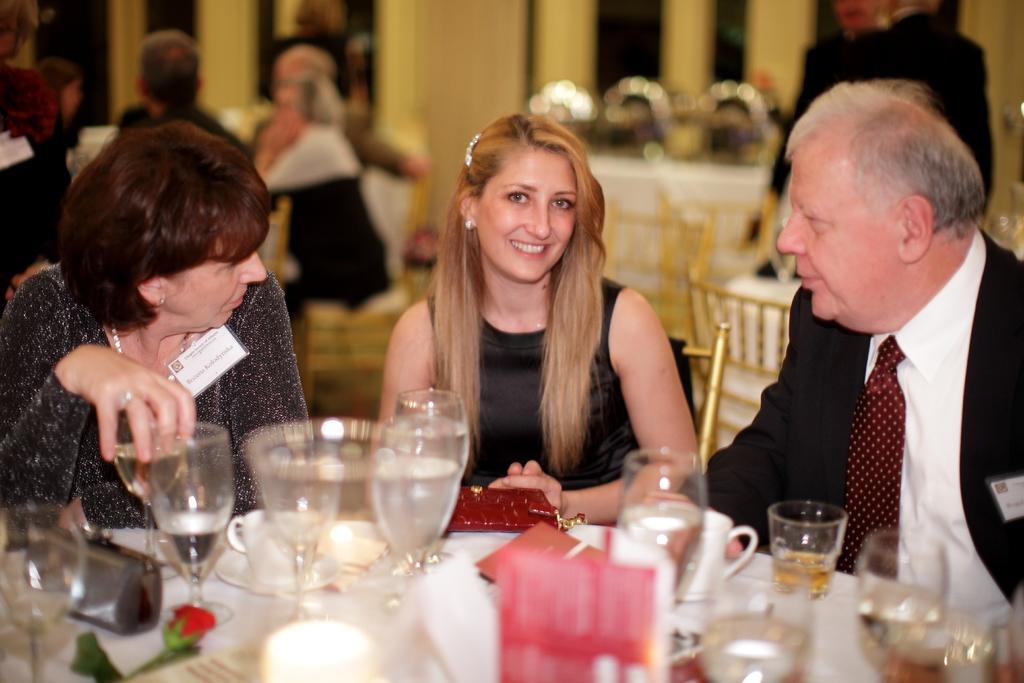Please provide a concise description of this image. In this image I can see two women and a man and are sitting on chairs, I can also see a smile on her face. Here on this table I can see number of glasses, cups and few plates. In the background I can see few more people. 